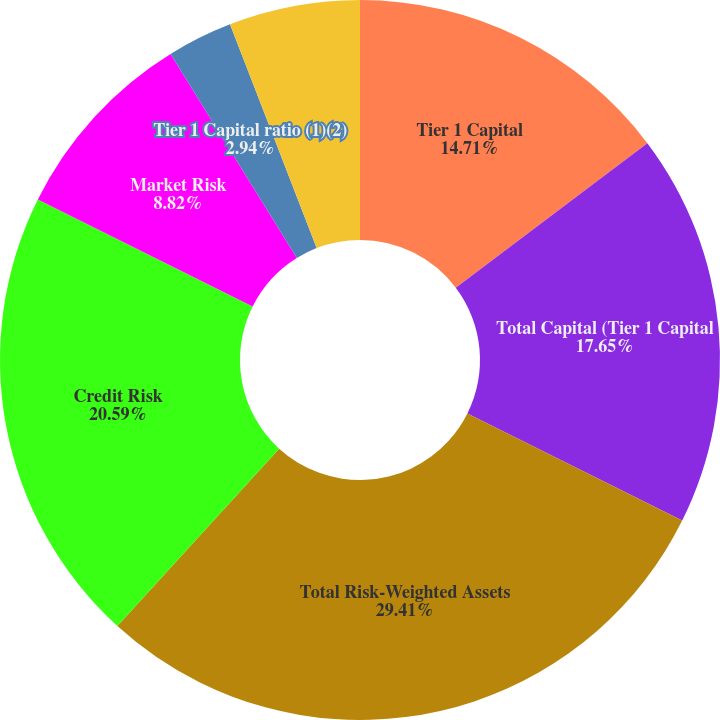<chart> <loc_0><loc_0><loc_500><loc_500><pie_chart><fcel>Common Equity Tier 1 Capital<fcel>Tier 1 Capital<fcel>Total Capital (Tier 1 Capital<fcel>Total Risk-Weighted Assets<fcel>Credit Risk<fcel>Market Risk<fcel>Tier 1 Capital ratio (1)(2)<fcel>Total Capital ratio (1)(2)<nl><fcel>0.0%<fcel>14.71%<fcel>17.65%<fcel>29.41%<fcel>20.59%<fcel>8.82%<fcel>2.94%<fcel>5.88%<nl></chart> 